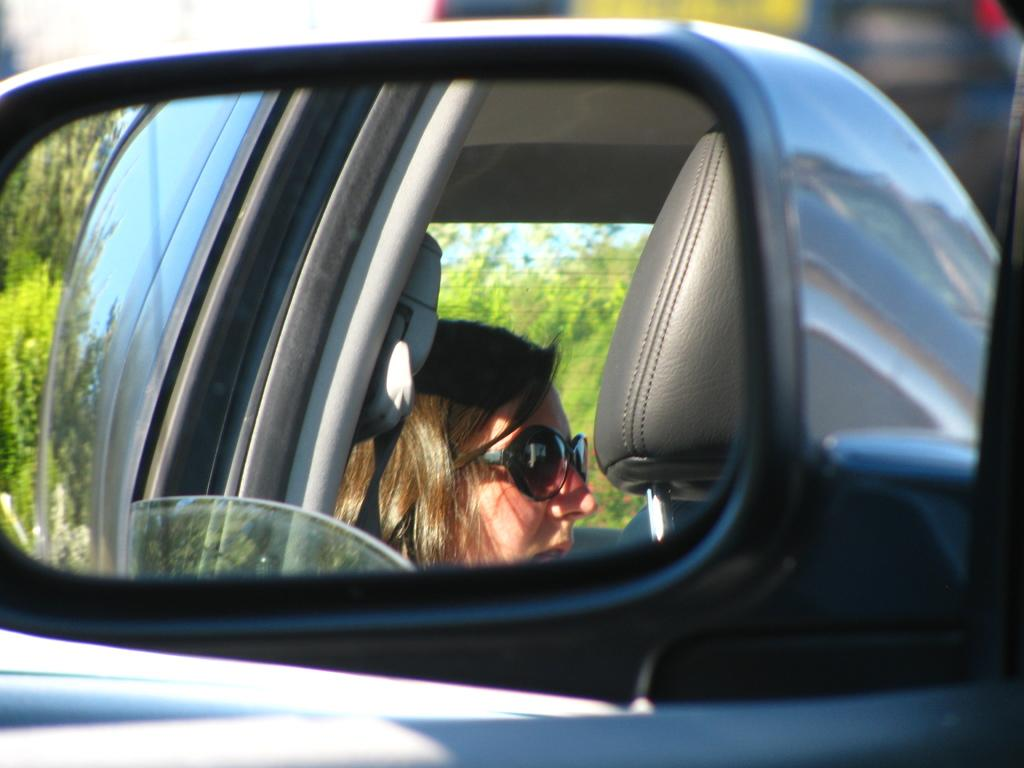What is the main subject of the image? The main subject of the image is a mirror of a vehicle. Can you describe the person visible through the glass? There is a lady visible through the glass, and she is wearing glasses. What can be seen in the background of the image? There are trees and other vehicles in the background of the image. What type of apple is the lady holding in the image? There is no apple present in the image; the lady is wearing glasses and there is no indication of her holding an apple. What is the lady learning in the image? There is no indication of the lady learning anything in the image; she is simply visible through the glass of the vehicle's mirror. 